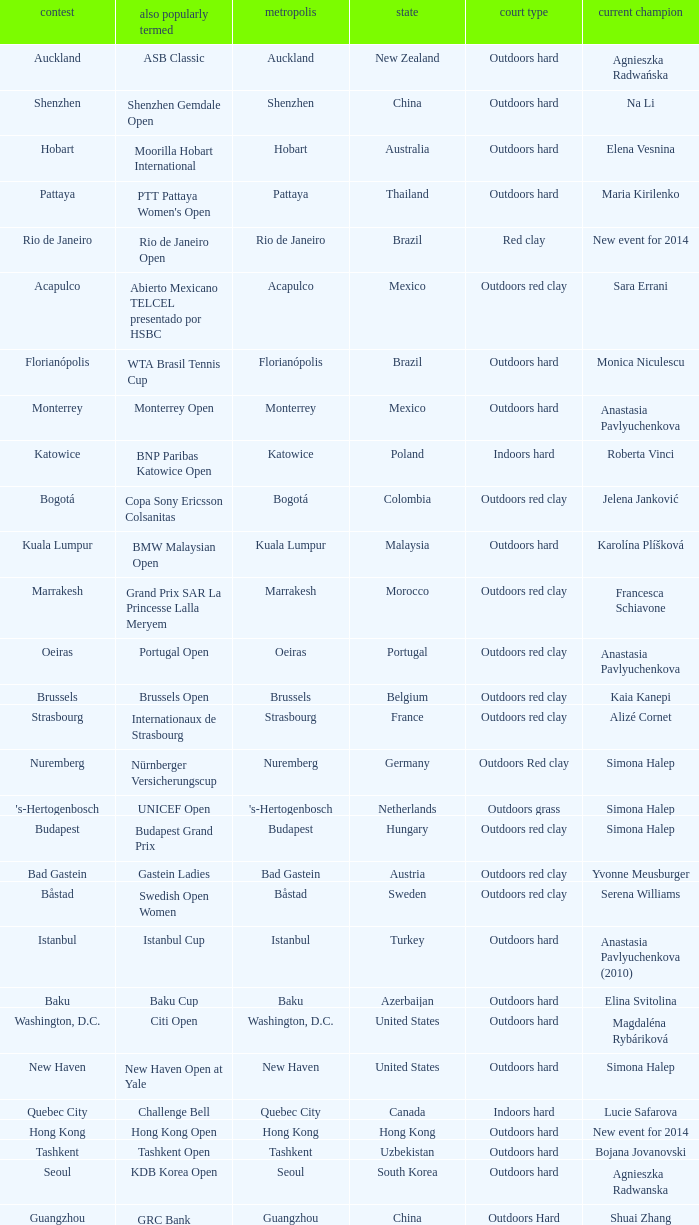How many tournaments are also currently known as the hp open? 1.0. 